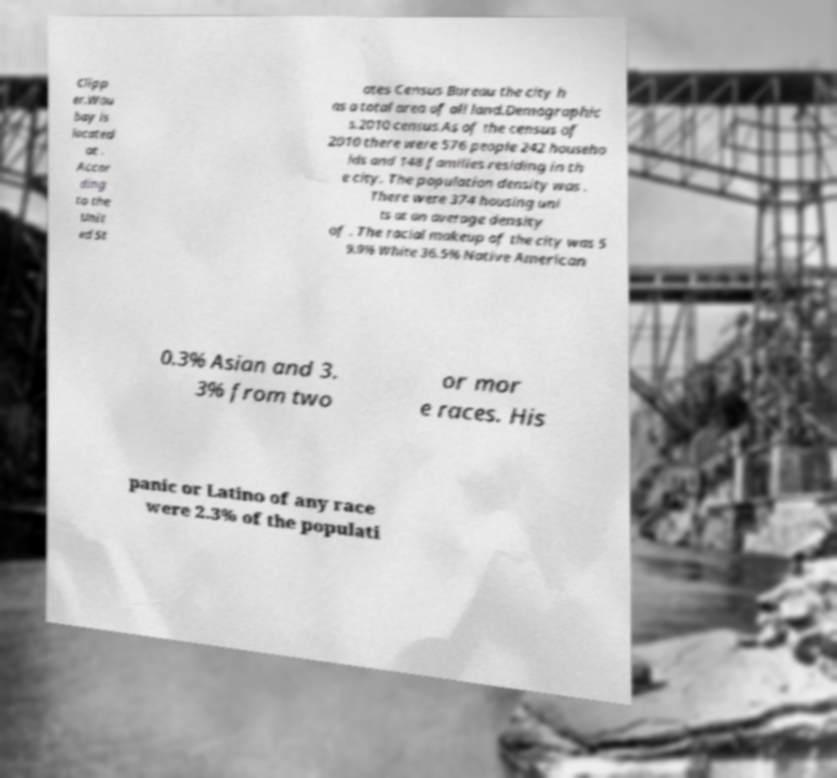Please identify and transcribe the text found in this image. Clipp er.Wau bay is located at . Accor ding to the Unit ed St ates Census Bureau the city h as a total area of all land.Demographic s.2010 census.As of the census of 2010 there were 576 people 242 househo lds and 148 families residing in th e city. The population density was . There were 374 housing uni ts at an average density of . The racial makeup of the city was 5 9.9% White 36.5% Native American 0.3% Asian and 3. 3% from two or mor e races. His panic or Latino of any race were 2.3% of the populati 